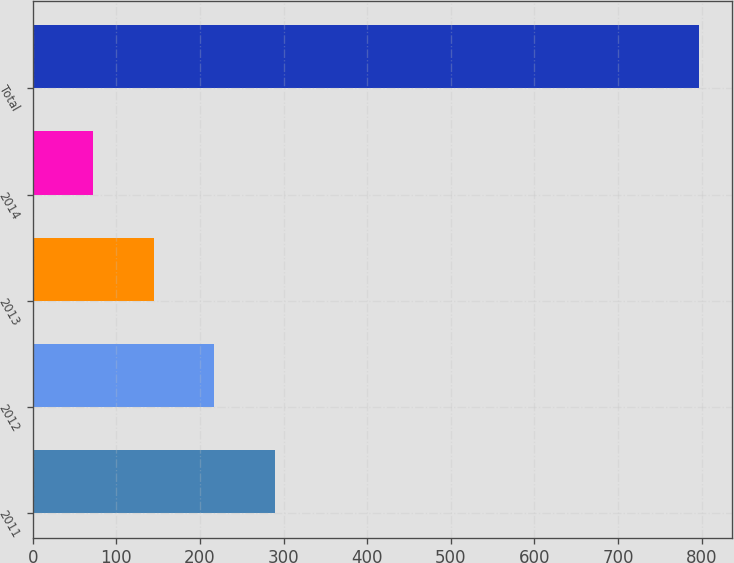Convert chart. <chart><loc_0><loc_0><loc_500><loc_500><bar_chart><fcel>2011<fcel>2012<fcel>2013<fcel>2014<fcel>Total<nl><fcel>289.5<fcel>217<fcel>144.5<fcel>72<fcel>797<nl></chart> 